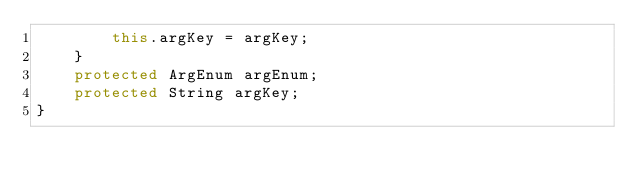<code> <loc_0><loc_0><loc_500><loc_500><_Java_>        this.argKey = argKey;
    }
    protected ArgEnum argEnum;
    protected String argKey;
}
</code> 